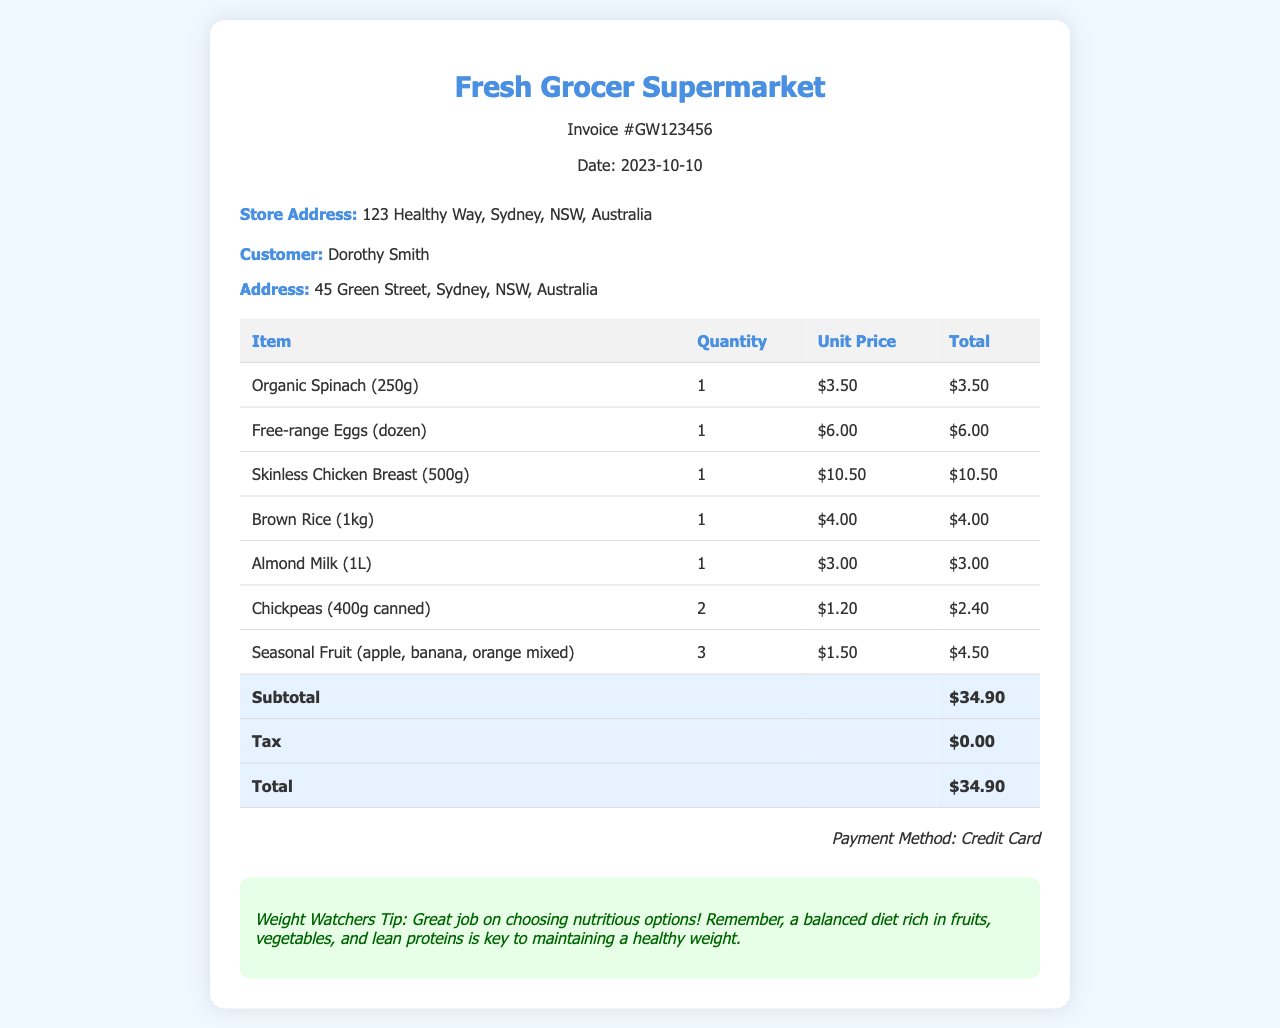What is the invoice number? The invoice number is specified at the top of the document under the invoice title.
Answer: GW123456 What is the date of the invoice? The date is provided right below the invoice number in the header section.
Answer: 2023-10-10 What was the total cost of the groceries? The total cost is listed at the bottom of the table under the total row.
Answer: $34.90 What payment method was used? The payment method is mentioned at the end of the invoice.
Answer: Credit Card How many organic spinach packages were purchased? The quantity of organic spinach is indicated in the table next to the item description.
Answer: 1 What is the price of skinless chicken breast? The unit price of skinless chicken breast can be found in the unit price column of the table.
Answer: $10.50 What healthy tip was provided? The healthy tip is included in a dedicated section at the bottom of the invoice.
Answer: Great job on choosing nutritious options! What is the subtotal before tax? The subtotal is calculated from the total of all items before considering tax, located in the total row.
Answer: $34.90 How many chickpeas cans were bought? The quantity of chickpeas is specified in the table under the quantity column.
Answer: 2 